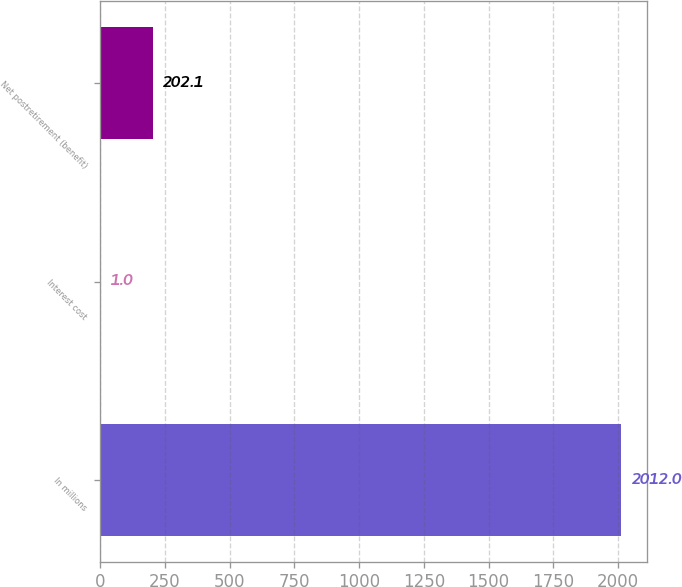<chart> <loc_0><loc_0><loc_500><loc_500><bar_chart><fcel>In millions<fcel>Interest cost<fcel>Net postretirement (benefit)<nl><fcel>2012<fcel>1<fcel>202.1<nl></chart> 